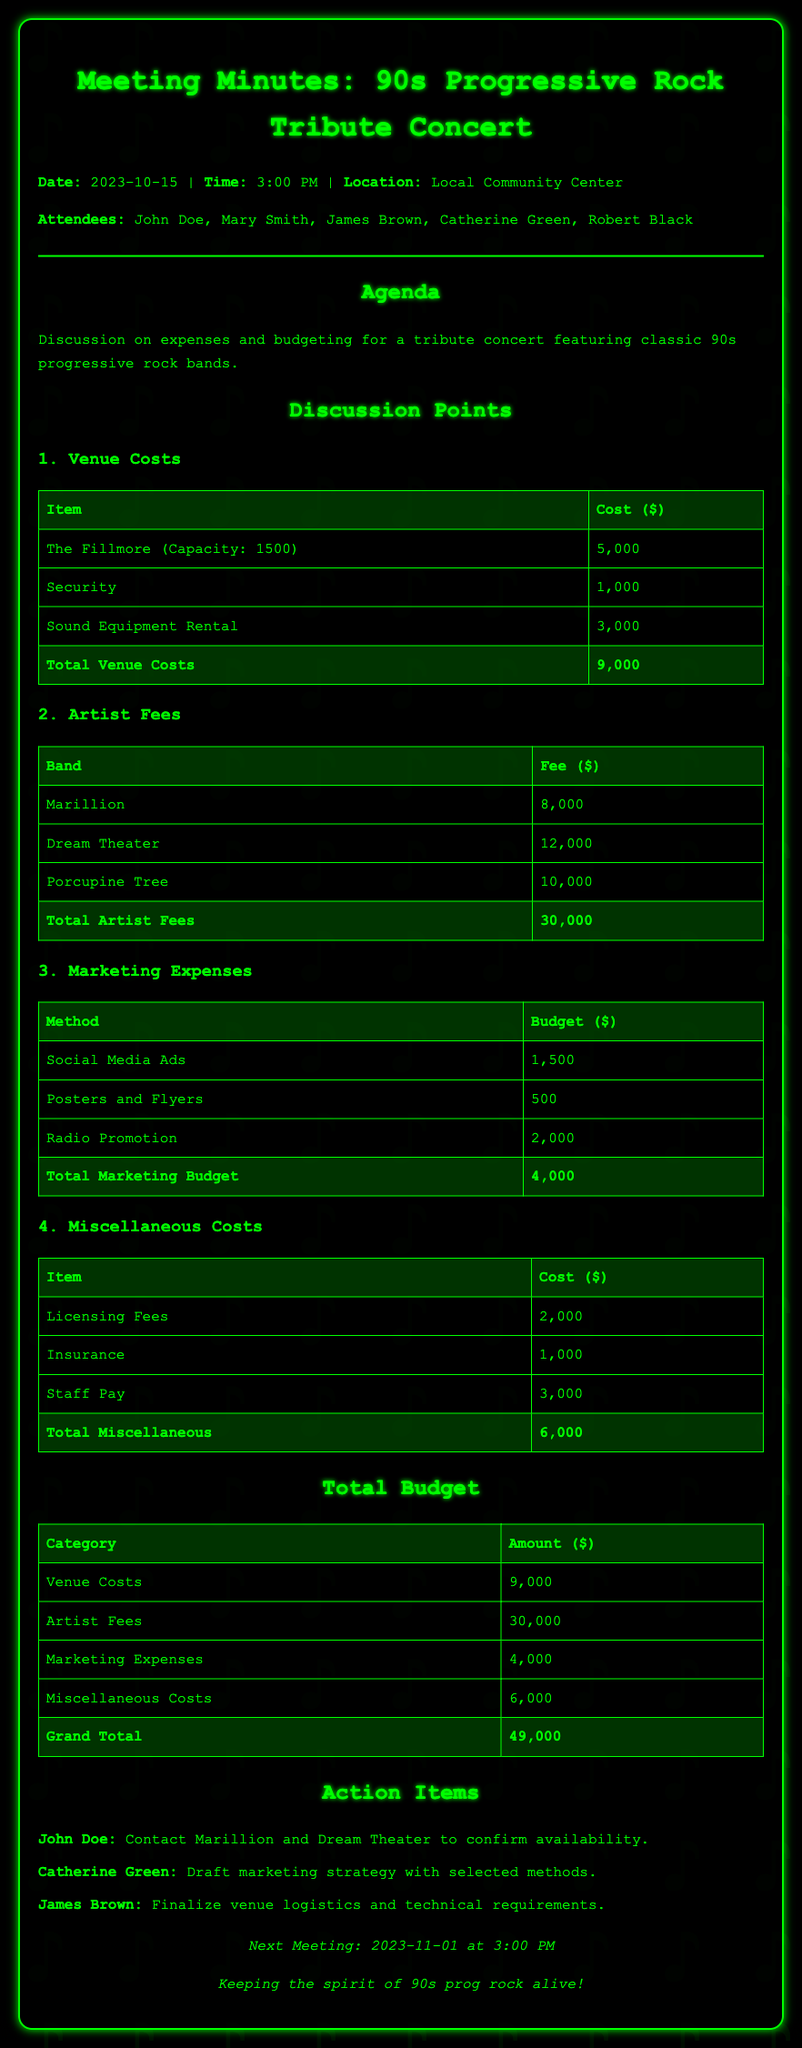what is the total venue cost? The total venue cost is listed under "Total Venue Costs" in the document as $9000.
Answer: $9000 how much is the fee for Dream Theater? The fee for Dream Theater is detailed in the "Artist Fees" section as $12000.
Answer: $12000 what are the total marketing expenses? The total marketing expenses can be found under "Total Marketing Budget" in the document, which is $4000.
Answer: $4000 who is responsible for drafting the marketing strategy? Catherine Green is mentioned in the action items as the person responsible for drafting the marketing strategy.
Answer: Catherine Green what is the grand total budget for the concert? The grand total budget is summarized in the "Total Budget" section as $49000.
Answer: $49000 how much will be spent on security? The cost for security is indicated as $1000 in the "Venue Costs" section.
Answer: $1000 which bands will be contacted for availability? The bands to be contacted for availability are Marillion and Dream Theater as assigned to John Doe.
Answer: Marillion and Dream Theater when is the next meeting scheduled? The next meeting is noted at the end of the document as being on 2023-11-01 at 3:00 PM.
Answer: 2023-11-01 at 3:00 PM 